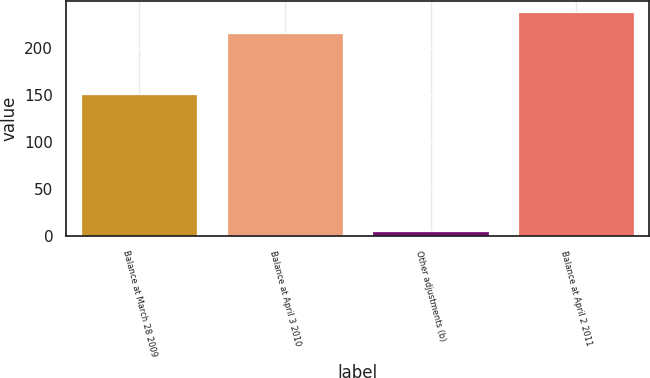Convert chart to OTSL. <chart><loc_0><loc_0><loc_500><loc_500><bar_chart><fcel>Balance at March 28 2009<fcel>Balance at April 3 2010<fcel>Other adjustments (b)<fcel>Balance at April 2 2011<nl><fcel>150.8<fcel>215.8<fcel>5.8<fcel>237.76<nl></chart> 